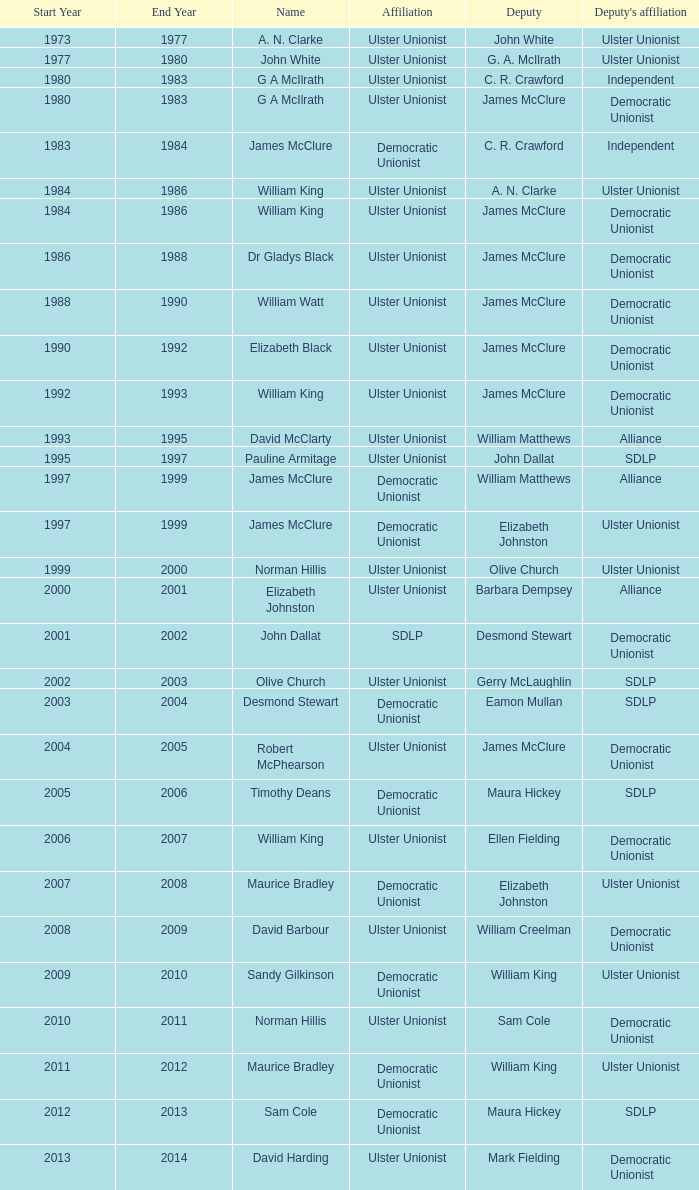What Year was james mcclure Deputy, and the Name is robert mcphearson? 2004–2005. 